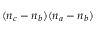Convert formula to latex. <formula><loc_0><loc_0><loc_500><loc_500>( n _ { c } - n _ { b } ) ( n _ { a } - n _ { b } )</formula> 